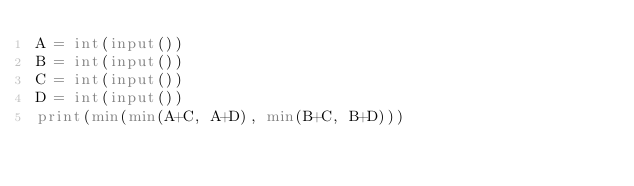Convert code to text. <code><loc_0><loc_0><loc_500><loc_500><_Python_>A = int(input())
B = int(input())
C = int(input())
D = int(input())
print(min(min(A+C, A+D), min(B+C, B+D)))</code> 